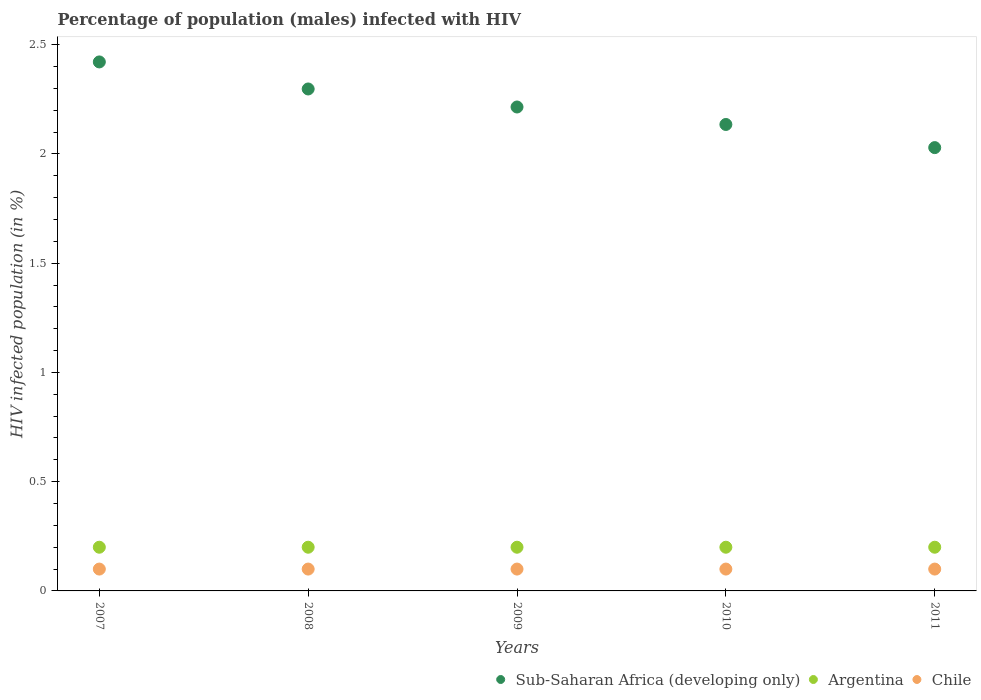How many different coloured dotlines are there?
Keep it short and to the point. 3. Is the number of dotlines equal to the number of legend labels?
Ensure brevity in your answer.  Yes. What is the percentage of HIV infected male population in Argentina in 2010?
Your response must be concise. 0.2. Across all years, what is the maximum percentage of HIV infected male population in Chile?
Provide a succinct answer. 0.1. Across all years, what is the minimum percentage of HIV infected male population in Sub-Saharan Africa (developing only)?
Offer a terse response. 2.03. What is the total percentage of HIV infected male population in Argentina in the graph?
Give a very brief answer. 1. What is the difference between the percentage of HIV infected male population in Argentina in 2011 and the percentage of HIV infected male population in Sub-Saharan Africa (developing only) in 2008?
Provide a short and direct response. -2.1. What is the average percentage of HIV infected male population in Chile per year?
Ensure brevity in your answer.  0.1. In the year 2008, what is the difference between the percentage of HIV infected male population in Chile and percentage of HIV infected male population in Sub-Saharan Africa (developing only)?
Make the answer very short. -2.2. In how many years, is the percentage of HIV infected male population in Sub-Saharan Africa (developing only) greater than 1.7 %?
Your response must be concise. 5. What is the ratio of the percentage of HIV infected male population in Chile in 2008 to that in 2010?
Your answer should be compact. 1. Is the percentage of HIV infected male population in Chile in 2009 less than that in 2010?
Ensure brevity in your answer.  No. What is the difference between the highest and the second highest percentage of HIV infected male population in Chile?
Give a very brief answer. 0. What is the difference between the highest and the lowest percentage of HIV infected male population in Argentina?
Your answer should be compact. 0. Is the sum of the percentage of HIV infected male population in Chile in 2009 and 2010 greater than the maximum percentage of HIV infected male population in Argentina across all years?
Offer a terse response. No. Does the percentage of HIV infected male population in Chile monotonically increase over the years?
Your response must be concise. No. Is the percentage of HIV infected male population in Chile strictly greater than the percentage of HIV infected male population in Argentina over the years?
Ensure brevity in your answer.  No. Is the percentage of HIV infected male population in Sub-Saharan Africa (developing only) strictly less than the percentage of HIV infected male population in Chile over the years?
Keep it short and to the point. No. How many dotlines are there?
Ensure brevity in your answer.  3. What is the difference between two consecutive major ticks on the Y-axis?
Keep it short and to the point. 0.5. Are the values on the major ticks of Y-axis written in scientific E-notation?
Make the answer very short. No. Does the graph contain any zero values?
Ensure brevity in your answer.  No. Does the graph contain grids?
Your answer should be very brief. No. Where does the legend appear in the graph?
Keep it short and to the point. Bottom right. How many legend labels are there?
Give a very brief answer. 3. How are the legend labels stacked?
Keep it short and to the point. Horizontal. What is the title of the graph?
Provide a short and direct response. Percentage of population (males) infected with HIV. What is the label or title of the X-axis?
Provide a short and direct response. Years. What is the label or title of the Y-axis?
Your answer should be very brief. HIV infected population (in %). What is the HIV infected population (in %) in Sub-Saharan Africa (developing only) in 2007?
Offer a terse response. 2.42. What is the HIV infected population (in %) in Sub-Saharan Africa (developing only) in 2008?
Keep it short and to the point. 2.3. What is the HIV infected population (in %) in Chile in 2008?
Your answer should be compact. 0.1. What is the HIV infected population (in %) in Sub-Saharan Africa (developing only) in 2009?
Offer a terse response. 2.21. What is the HIV infected population (in %) in Argentina in 2009?
Give a very brief answer. 0.2. What is the HIV infected population (in %) in Sub-Saharan Africa (developing only) in 2010?
Provide a short and direct response. 2.13. What is the HIV infected population (in %) in Chile in 2010?
Your answer should be very brief. 0.1. What is the HIV infected population (in %) of Sub-Saharan Africa (developing only) in 2011?
Your response must be concise. 2.03. Across all years, what is the maximum HIV infected population (in %) of Sub-Saharan Africa (developing only)?
Provide a short and direct response. 2.42. Across all years, what is the maximum HIV infected population (in %) in Chile?
Offer a terse response. 0.1. Across all years, what is the minimum HIV infected population (in %) of Sub-Saharan Africa (developing only)?
Your answer should be very brief. 2.03. Across all years, what is the minimum HIV infected population (in %) in Argentina?
Offer a terse response. 0.2. Across all years, what is the minimum HIV infected population (in %) of Chile?
Provide a short and direct response. 0.1. What is the total HIV infected population (in %) in Sub-Saharan Africa (developing only) in the graph?
Give a very brief answer. 11.1. What is the total HIV infected population (in %) of Argentina in the graph?
Provide a short and direct response. 1. What is the difference between the HIV infected population (in %) in Sub-Saharan Africa (developing only) in 2007 and that in 2008?
Make the answer very short. 0.12. What is the difference between the HIV infected population (in %) of Sub-Saharan Africa (developing only) in 2007 and that in 2009?
Provide a succinct answer. 0.21. What is the difference between the HIV infected population (in %) of Chile in 2007 and that in 2009?
Provide a short and direct response. 0. What is the difference between the HIV infected population (in %) in Sub-Saharan Africa (developing only) in 2007 and that in 2010?
Provide a succinct answer. 0.29. What is the difference between the HIV infected population (in %) in Sub-Saharan Africa (developing only) in 2007 and that in 2011?
Offer a terse response. 0.39. What is the difference between the HIV infected population (in %) of Chile in 2007 and that in 2011?
Give a very brief answer. 0. What is the difference between the HIV infected population (in %) in Sub-Saharan Africa (developing only) in 2008 and that in 2009?
Provide a succinct answer. 0.08. What is the difference between the HIV infected population (in %) in Argentina in 2008 and that in 2009?
Your answer should be very brief. 0. What is the difference between the HIV infected population (in %) in Chile in 2008 and that in 2009?
Offer a very short reply. 0. What is the difference between the HIV infected population (in %) in Sub-Saharan Africa (developing only) in 2008 and that in 2010?
Offer a very short reply. 0.16. What is the difference between the HIV infected population (in %) of Argentina in 2008 and that in 2010?
Ensure brevity in your answer.  0. What is the difference between the HIV infected population (in %) in Sub-Saharan Africa (developing only) in 2008 and that in 2011?
Your answer should be compact. 0.27. What is the difference between the HIV infected population (in %) of Chile in 2008 and that in 2011?
Give a very brief answer. 0. What is the difference between the HIV infected population (in %) of Chile in 2009 and that in 2010?
Your answer should be very brief. 0. What is the difference between the HIV infected population (in %) in Sub-Saharan Africa (developing only) in 2009 and that in 2011?
Provide a succinct answer. 0.19. What is the difference between the HIV infected population (in %) of Sub-Saharan Africa (developing only) in 2010 and that in 2011?
Your response must be concise. 0.11. What is the difference between the HIV infected population (in %) of Chile in 2010 and that in 2011?
Your answer should be very brief. 0. What is the difference between the HIV infected population (in %) in Sub-Saharan Africa (developing only) in 2007 and the HIV infected population (in %) in Argentina in 2008?
Your response must be concise. 2.22. What is the difference between the HIV infected population (in %) of Sub-Saharan Africa (developing only) in 2007 and the HIV infected population (in %) of Chile in 2008?
Provide a succinct answer. 2.32. What is the difference between the HIV infected population (in %) in Sub-Saharan Africa (developing only) in 2007 and the HIV infected population (in %) in Argentina in 2009?
Your response must be concise. 2.22. What is the difference between the HIV infected population (in %) in Sub-Saharan Africa (developing only) in 2007 and the HIV infected population (in %) in Chile in 2009?
Your response must be concise. 2.32. What is the difference between the HIV infected population (in %) of Argentina in 2007 and the HIV infected population (in %) of Chile in 2009?
Provide a succinct answer. 0.1. What is the difference between the HIV infected population (in %) in Sub-Saharan Africa (developing only) in 2007 and the HIV infected population (in %) in Argentina in 2010?
Give a very brief answer. 2.22. What is the difference between the HIV infected population (in %) in Sub-Saharan Africa (developing only) in 2007 and the HIV infected population (in %) in Chile in 2010?
Your response must be concise. 2.32. What is the difference between the HIV infected population (in %) of Sub-Saharan Africa (developing only) in 2007 and the HIV infected population (in %) of Argentina in 2011?
Your answer should be compact. 2.22. What is the difference between the HIV infected population (in %) in Sub-Saharan Africa (developing only) in 2007 and the HIV infected population (in %) in Chile in 2011?
Provide a short and direct response. 2.32. What is the difference between the HIV infected population (in %) in Sub-Saharan Africa (developing only) in 2008 and the HIV infected population (in %) in Argentina in 2009?
Your answer should be very brief. 2.1. What is the difference between the HIV infected population (in %) of Sub-Saharan Africa (developing only) in 2008 and the HIV infected population (in %) of Chile in 2009?
Provide a short and direct response. 2.2. What is the difference between the HIV infected population (in %) of Sub-Saharan Africa (developing only) in 2008 and the HIV infected population (in %) of Argentina in 2010?
Give a very brief answer. 2.1. What is the difference between the HIV infected population (in %) of Sub-Saharan Africa (developing only) in 2008 and the HIV infected population (in %) of Chile in 2010?
Offer a very short reply. 2.2. What is the difference between the HIV infected population (in %) of Argentina in 2008 and the HIV infected population (in %) of Chile in 2010?
Offer a terse response. 0.1. What is the difference between the HIV infected population (in %) of Sub-Saharan Africa (developing only) in 2008 and the HIV infected population (in %) of Argentina in 2011?
Keep it short and to the point. 2.1. What is the difference between the HIV infected population (in %) in Sub-Saharan Africa (developing only) in 2008 and the HIV infected population (in %) in Chile in 2011?
Make the answer very short. 2.2. What is the difference between the HIV infected population (in %) of Sub-Saharan Africa (developing only) in 2009 and the HIV infected population (in %) of Argentina in 2010?
Your answer should be very brief. 2.01. What is the difference between the HIV infected population (in %) in Sub-Saharan Africa (developing only) in 2009 and the HIV infected population (in %) in Chile in 2010?
Give a very brief answer. 2.11. What is the difference between the HIV infected population (in %) in Argentina in 2009 and the HIV infected population (in %) in Chile in 2010?
Make the answer very short. 0.1. What is the difference between the HIV infected population (in %) in Sub-Saharan Africa (developing only) in 2009 and the HIV infected population (in %) in Argentina in 2011?
Offer a terse response. 2.01. What is the difference between the HIV infected population (in %) of Sub-Saharan Africa (developing only) in 2009 and the HIV infected population (in %) of Chile in 2011?
Offer a terse response. 2.11. What is the difference between the HIV infected population (in %) in Argentina in 2009 and the HIV infected population (in %) in Chile in 2011?
Provide a short and direct response. 0.1. What is the difference between the HIV infected population (in %) in Sub-Saharan Africa (developing only) in 2010 and the HIV infected population (in %) in Argentina in 2011?
Offer a very short reply. 1.93. What is the difference between the HIV infected population (in %) of Sub-Saharan Africa (developing only) in 2010 and the HIV infected population (in %) of Chile in 2011?
Provide a short and direct response. 2.03. What is the average HIV infected population (in %) of Sub-Saharan Africa (developing only) per year?
Provide a short and direct response. 2.22. What is the average HIV infected population (in %) of Chile per year?
Offer a very short reply. 0.1. In the year 2007, what is the difference between the HIV infected population (in %) of Sub-Saharan Africa (developing only) and HIV infected population (in %) of Argentina?
Offer a terse response. 2.22. In the year 2007, what is the difference between the HIV infected population (in %) of Sub-Saharan Africa (developing only) and HIV infected population (in %) of Chile?
Ensure brevity in your answer.  2.32. In the year 2007, what is the difference between the HIV infected population (in %) of Argentina and HIV infected population (in %) of Chile?
Your answer should be very brief. 0.1. In the year 2008, what is the difference between the HIV infected population (in %) of Sub-Saharan Africa (developing only) and HIV infected population (in %) of Argentina?
Offer a terse response. 2.1. In the year 2008, what is the difference between the HIV infected population (in %) in Sub-Saharan Africa (developing only) and HIV infected population (in %) in Chile?
Your answer should be very brief. 2.2. In the year 2009, what is the difference between the HIV infected population (in %) in Sub-Saharan Africa (developing only) and HIV infected population (in %) in Argentina?
Your response must be concise. 2.01. In the year 2009, what is the difference between the HIV infected population (in %) in Sub-Saharan Africa (developing only) and HIV infected population (in %) in Chile?
Ensure brevity in your answer.  2.11. In the year 2010, what is the difference between the HIV infected population (in %) of Sub-Saharan Africa (developing only) and HIV infected population (in %) of Argentina?
Your answer should be compact. 1.93. In the year 2010, what is the difference between the HIV infected population (in %) of Sub-Saharan Africa (developing only) and HIV infected population (in %) of Chile?
Give a very brief answer. 2.03. In the year 2010, what is the difference between the HIV infected population (in %) in Argentina and HIV infected population (in %) in Chile?
Make the answer very short. 0.1. In the year 2011, what is the difference between the HIV infected population (in %) in Sub-Saharan Africa (developing only) and HIV infected population (in %) in Argentina?
Give a very brief answer. 1.83. In the year 2011, what is the difference between the HIV infected population (in %) in Sub-Saharan Africa (developing only) and HIV infected population (in %) in Chile?
Keep it short and to the point. 1.93. In the year 2011, what is the difference between the HIV infected population (in %) in Argentina and HIV infected population (in %) in Chile?
Provide a succinct answer. 0.1. What is the ratio of the HIV infected population (in %) in Sub-Saharan Africa (developing only) in 2007 to that in 2008?
Give a very brief answer. 1.05. What is the ratio of the HIV infected population (in %) in Argentina in 2007 to that in 2008?
Provide a succinct answer. 1. What is the ratio of the HIV infected population (in %) in Sub-Saharan Africa (developing only) in 2007 to that in 2009?
Keep it short and to the point. 1.09. What is the ratio of the HIV infected population (in %) of Chile in 2007 to that in 2009?
Give a very brief answer. 1. What is the ratio of the HIV infected population (in %) of Sub-Saharan Africa (developing only) in 2007 to that in 2010?
Your answer should be compact. 1.13. What is the ratio of the HIV infected population (in %) of Chile in 2007 to that in 2010?
Your answer should be very brief. 1. What is the ratio of the HIV infected population (in %) of Sub-Saharan Africa (developing only) in 2007 to that in 2011?
Ensure brevity in your answer.  1.19. What is the ratio of the HIV infected population (in %) in Chile in 2007 to that in 2011?
Give a very brief answer. 1. What is the ratio of the HIV infected population (in %) of Sub-Saharan Africa (developing only) in 2008 to that in 2009?
Your answer should be compact. 1.04. What is the ratio of the HIV infected population (in %) of Argentina in 2008 to that in 2009?
Make the answer very short. 1. What is the ratio of the HIV infected population (in %) in Sub-Saharan Africa (developing only) in 2008 to that in 2010?
Provide a short and direct response. 1.08. What is the ratio of the HIV infected population (in %) in Argentina in 2008 to that in 2010?
Offer a very short reply. 1. What is the ratio of the HIV infected population (in %) in Sub-Saharan Africa (developing only) in 2008 to that in 2011?
Give a very brief answer. 1.13. What is the ratio of the HIV infected population (in %) in Sub-Saharan Africa (developing only) in 2009 to that in 2010?
Offer a very short reply. 1.04. What is the ratio of the HIV infected population (in %) in Sub-Saharan Africa (developing only) in 2009 to that in 2011?
Provide a short and direct response. 1.09. What is the ratio of the HIV infected population (in %) of Argentina in 2009 to that in 2011?
Your response must be concise. 1. What is the ratio of the HIV infected population (in %) in Sub-Saharan Africa (developing only) in 2010 to that in 2011?
Your answer should be compact. 1.05. What is the ratio of the HIV infected population (in %) in Argentina in 2010 to that in 2011?
Your response must be concise. 1. What is the difference between the highest and the second highest HIV infected population (in %) in Sub-Saharan Africa (developing only)?
Keep it short and to the point. 0.12. What is the difference between the highest and the second highest HIV infected population (in %) of Argentina?
Offer a terse response. 0. What is the difference between the highest and the second highest HIV infected population (in %) of Chile?
Give a very brief answer. 0. What is the difference between the highest and the lowest HIV infected population (in %) in Sub-Saharan Africa (developing only)?
Ensure brevity in your answer.  0.39. What is the difference between the highest and the lowest HIV infected population (in %) in Argentina?
Your response must be concise. 0. What is the difference between the highest and the lowest HIV infected population (in %) in Chile?
Your answer should be compact. 0. 